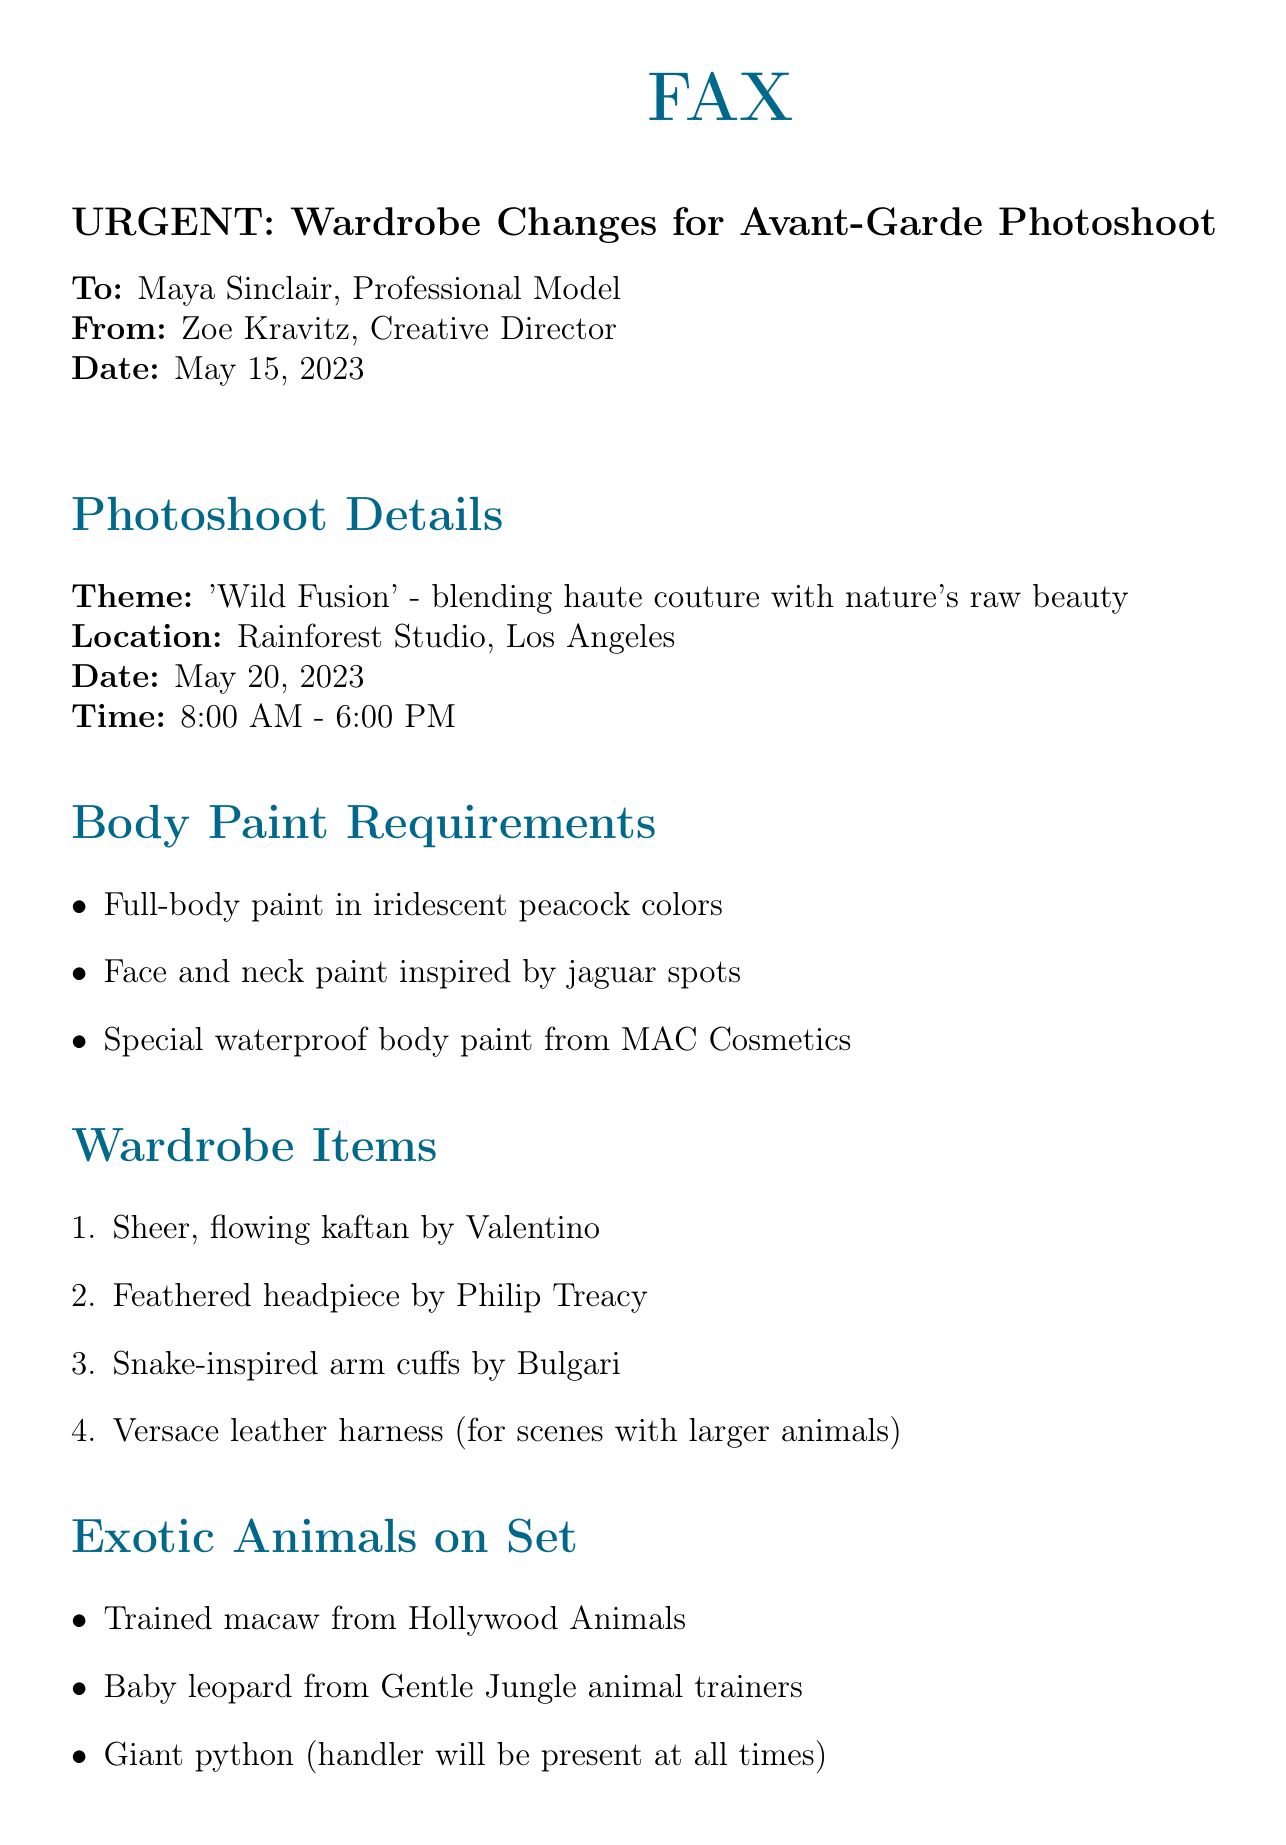what is the theme of the photoshoot? The theme is explicitly mentioned in the document as 'Wild Fusion' which blends haute couture with nature's raw beauty.
Answer: 'Wild Fusion' what is the location of the photoshoot? The location is stated in the document as Rainforest Studio, Los Angeles.
Answer: Rainforest Studio, Los Angeles what item is required for face and neck paint? The document specifies that face and neck paint should be inspired by jaguar spots.
Answer: jaguar spots how many exotic animals will be on set? The document lists three exotic animals that will be present on the set.
Answer: three what is the time range for the photoshoot? The document provides the start and end time for the photoshoot as 8:00 AM to 6:00 PM.
Answer: 8:00 AM - 6:00 PM who is the creative director of the photoshoot? The document identifies Zoe Kravitz as the Creative Director.
Answer: Zoe Kravitz what should the model bring for paint removal? The document mentions that the model should bring hypoallergenic body lotion for easy paint removal.
Answer: hypoallergenic body lotion how early should the model arrive for body painting? According to the document, the model is instructed to arrive 2 hours early for body painting.
Answer: 2 hours early 